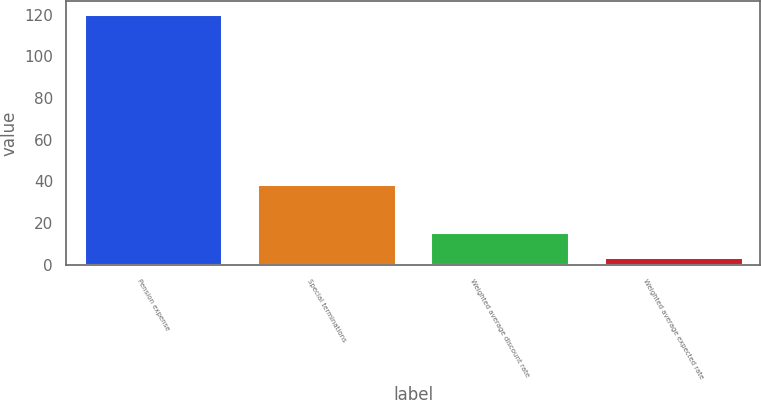Convert chart. <chart><loc_0><loc_0><loc_500><loc_500><bar_chart><fcel>Pension expense<fcel>Special terminations<fcel>Weighted average discount rate<fcel>Weighted average expected rate<nl><fcel>120.4<fcel>38.85<fcel>15.55<fcel>3.9<nl></chart> 